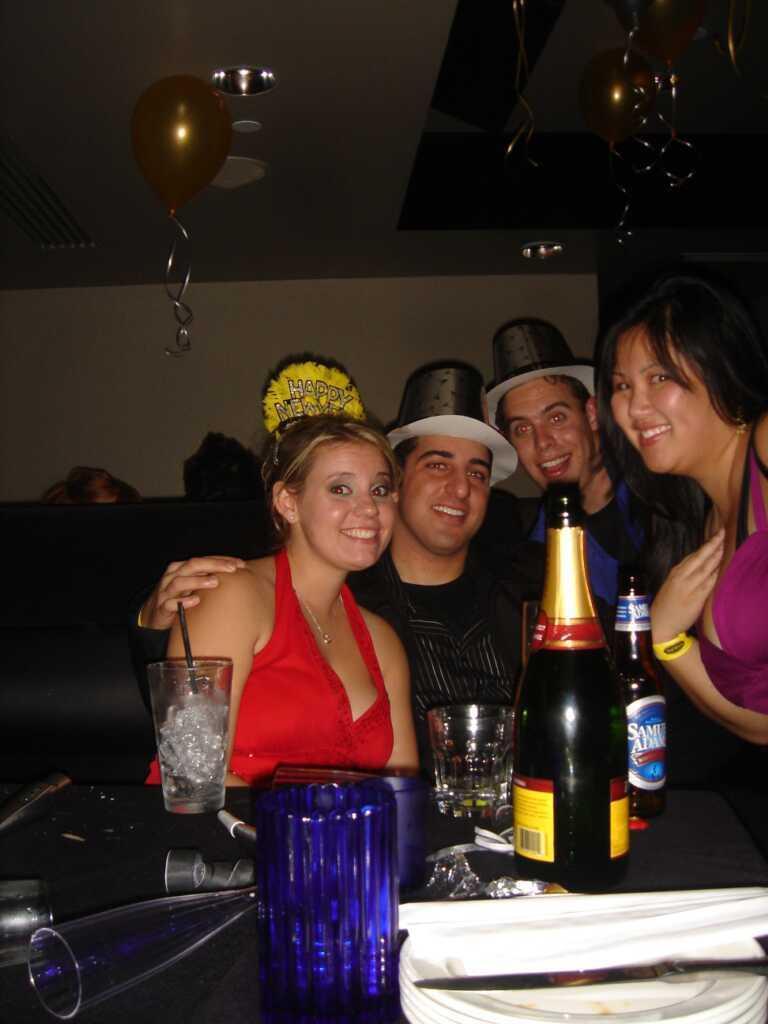Please provide a concise description of this image. In this image I can see the group of people with different color dresses. I can see two people with hats. In-front of these people I can see the bottles, glasses, plates, knife and few objects on the black color surface. I can see the balloons and the lights at the top. 